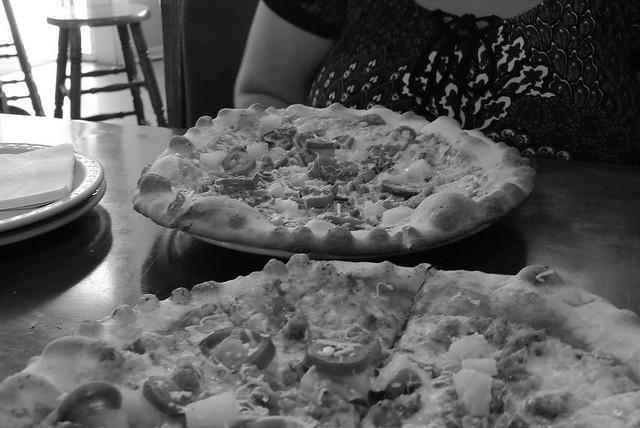Where was this food placed during cooking? Please explain your reasoning. oven. Ovens are commonly used for cooking pizza. 